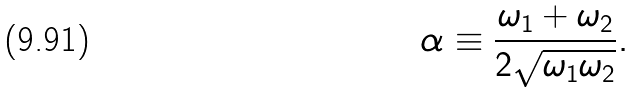Convert formula to latex. <formula><loc_0><loc_0><loc_500><loc_500>\alpha \equiv \frac { \omega _ { 1 } + \omega _ { 2 } } { 2 \sqrt { \omega _ { 1 } \omega _ { 2 } } } .</formula> 